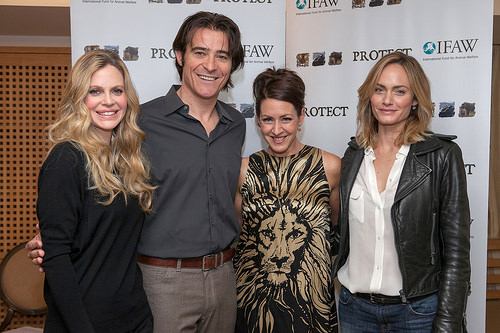<image>
Is there a girl to the left of the girl? Yes. From this viewpoint, the girl is positioned to the left side relative to the girl. 